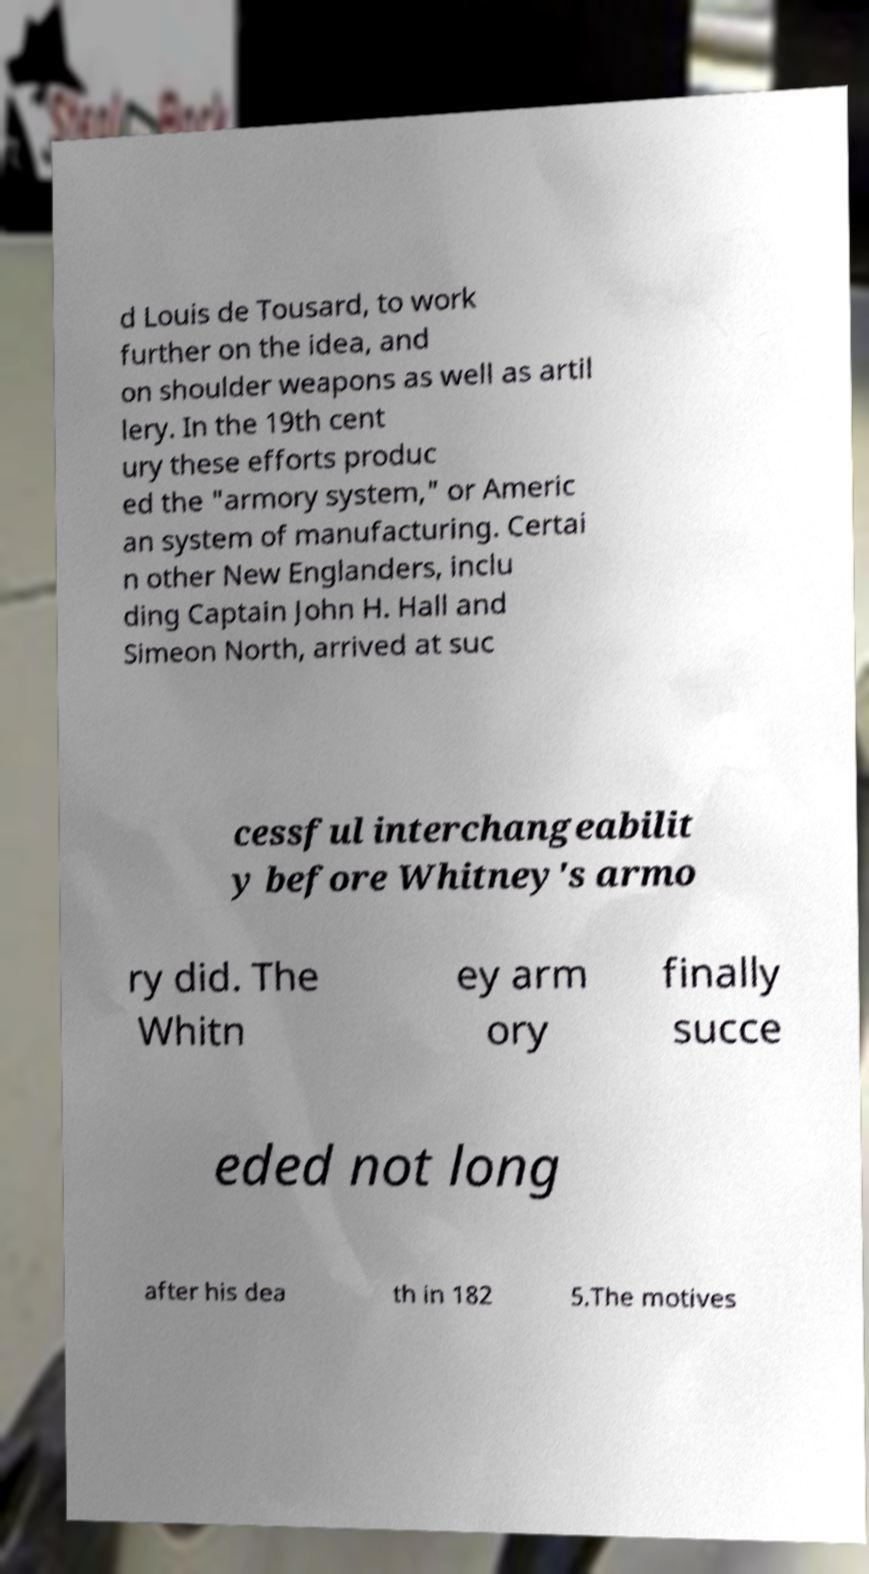Could you extract and type out the text from this image? d Louis de Tousard, to work further on the idea, and on shoulder weapons as well as artil lery. In the 19th cent ury these efforts produc ed the "armory system," or Americ an system of manufacturing. Certai n other New Englanders, inclu ding Captain John H. Hall and Simeon North, arrived at suc cessful interchangeabilit y before Whitney's armo ry did. The Whitn ey arm ory finally succe eded not long after his dea th in 182 5.The motives 